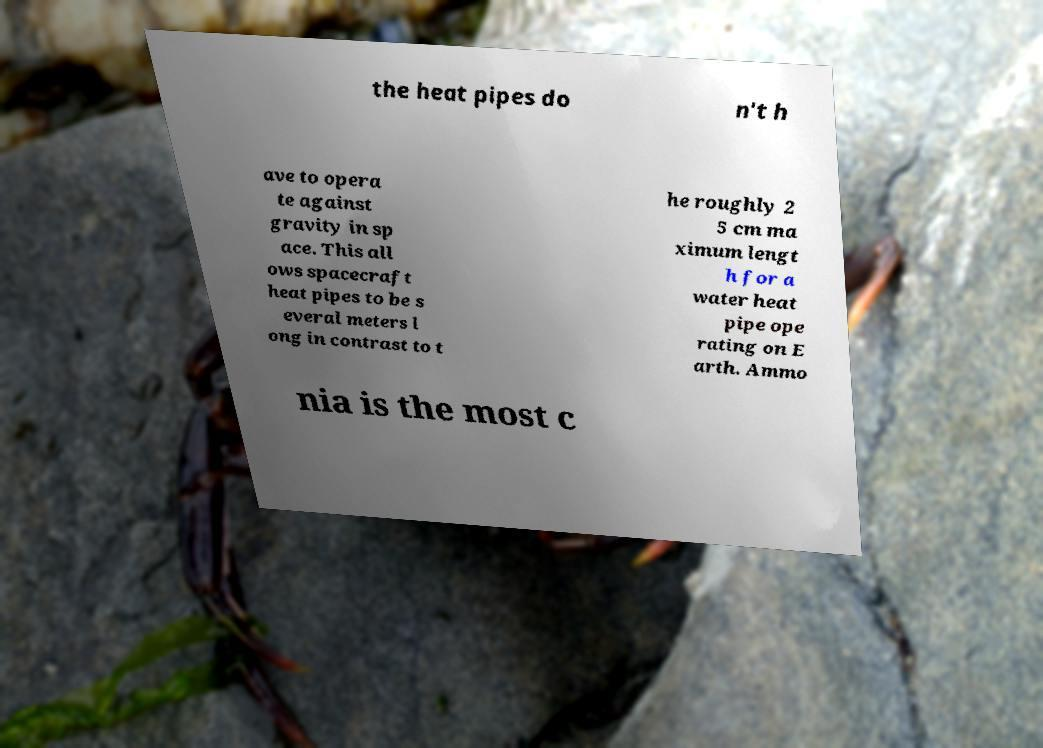Could you assist in decoding the text presented in this image and type it out clearly? the heat pipes do n't h ave to opera te against gravity in sp ace. This all ows spacecraft heat pipes to be s everal meters l ong in contrast to t he roughly 2 5 cm ma ximum lengt h for a water heat pipe ope rating on E arth. Ammo nia is the most c 